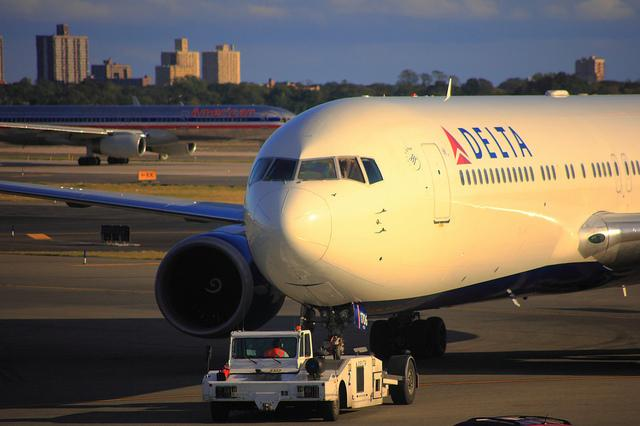What is the last letter of the name that appears on the plane? Please explain your reasoning. . N and w do not appear in the name. e is the second letter. 